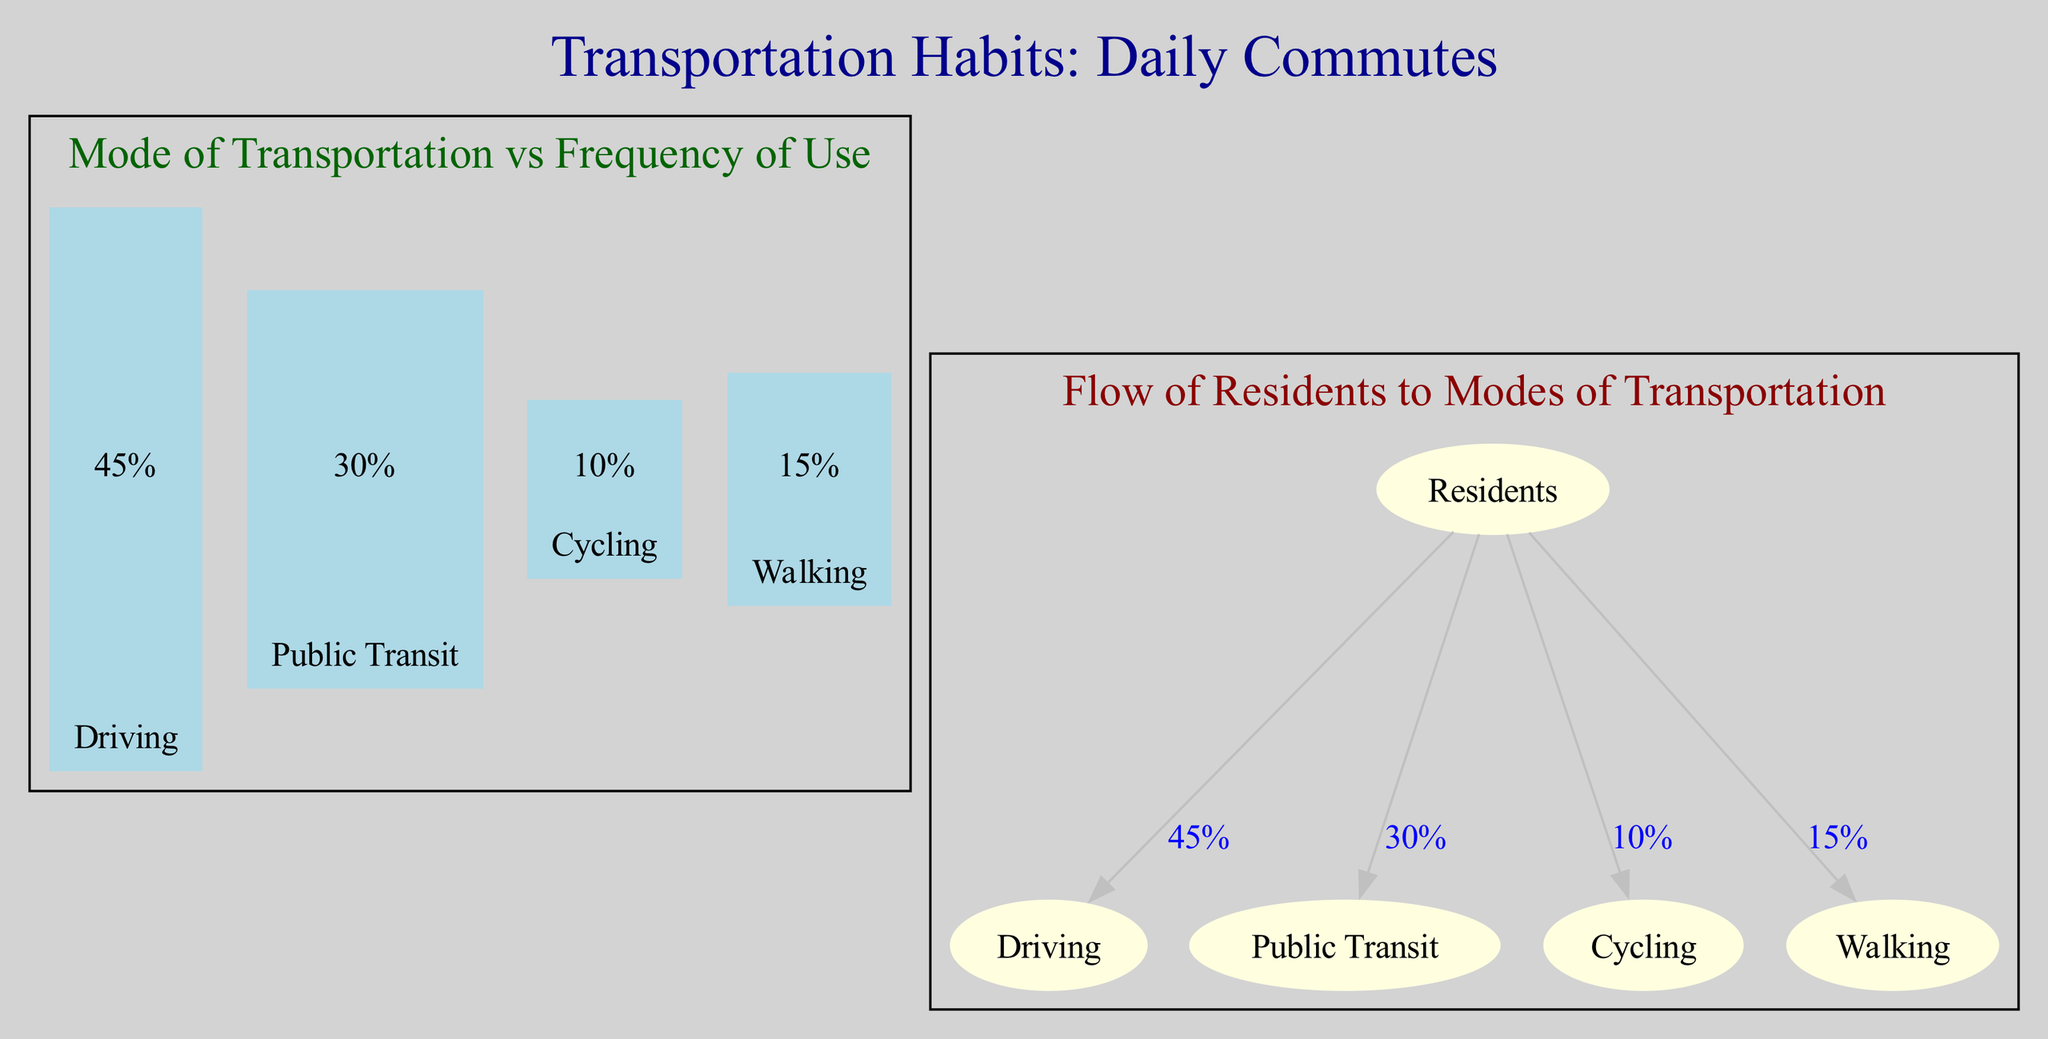What is the frequency of use for driving as a mode of transportation? The bar chart indicates that the frequency of use for driving is 45%, as shown by its data point in the chart.
Answer: 45% How many modes of transportation are represented in the diagram? The diagram distinguishes between four modes of transportation: Driving, Public Transit, Cycling, and Walking. Counting these gives a total of four modes.
Answer: 4 Which mode of transportation has the least frequency of use? In the bar chart, Cycling shows the lowest frequency of use at 10%, making it the least utilized mode among the options displayed.
Answer: Cycling What percentage of residents use public transit? The flowchart indicates that the percentage of residents using public transit is 30%, as denoted by the relevant arrow and label connecting residents to public transit.
Answer: 30% If the total number of residents is 1000, how many residents choose cycling for their daily commutes? With 10% of residents choosing cycling, we calculate 10% of 1000, which equals 100 residents opting for this mode of transportation.
Answer: 100 Which mode of transportation is used by more residents, driving or walking? By comparing the frequency values shown, Driving has 45% while Walking has 15%, thus driving is more utilized.
Answer: Driving How are the residents distributed among the different modes of transportation? The distribution can be seen by looking at the arrows and the label percentages in the flowchart: 45% driving, 30% public transit, 10% cycling, and 15% walking, indicating how the entire group of residents is segmented based on their choices.
Answer: Driving 45%, Public Transit 30%, Cycling 10%, Walking 15% What is the primary method of transportation among residents? The data shows that the primary method of transportation is Driving, claiming the highest frequency at 45%.
Answer: Driving What visual representation method is used for showing frequency in this diagram? The bar chart is the method employed to represent the frequency of use for different modes of transportation among residents visually.
Answer: Bar chart 